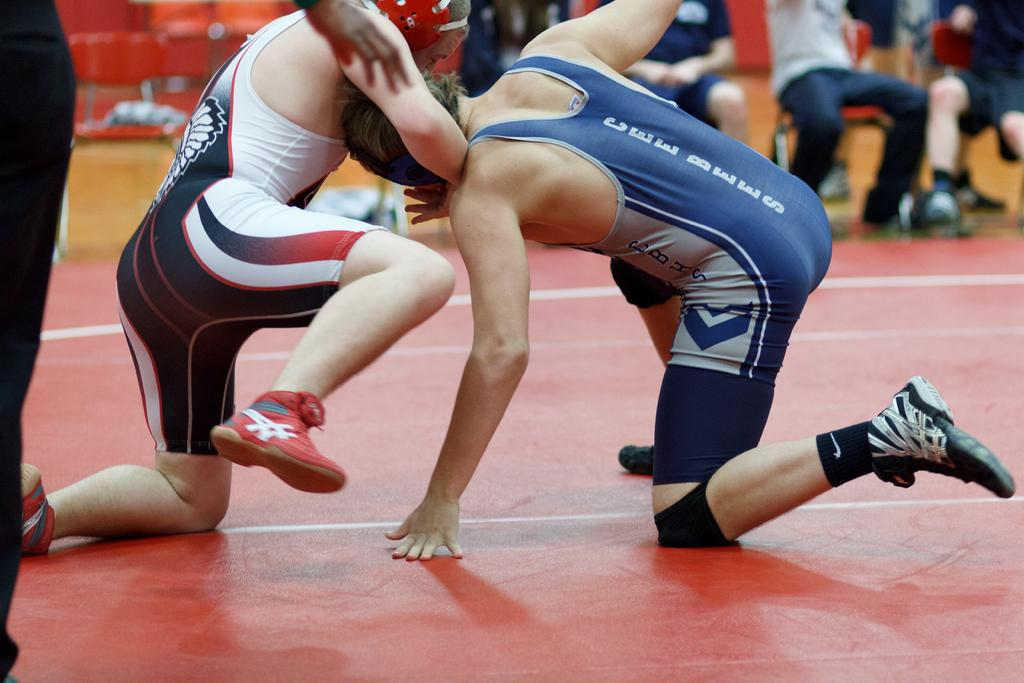<image>
Write a terse but informative summary of the picture. A man in a red, black, and white wrestling uniform has another man wearing a Cee Bees wrestling uniform, in a shoulder lock. 